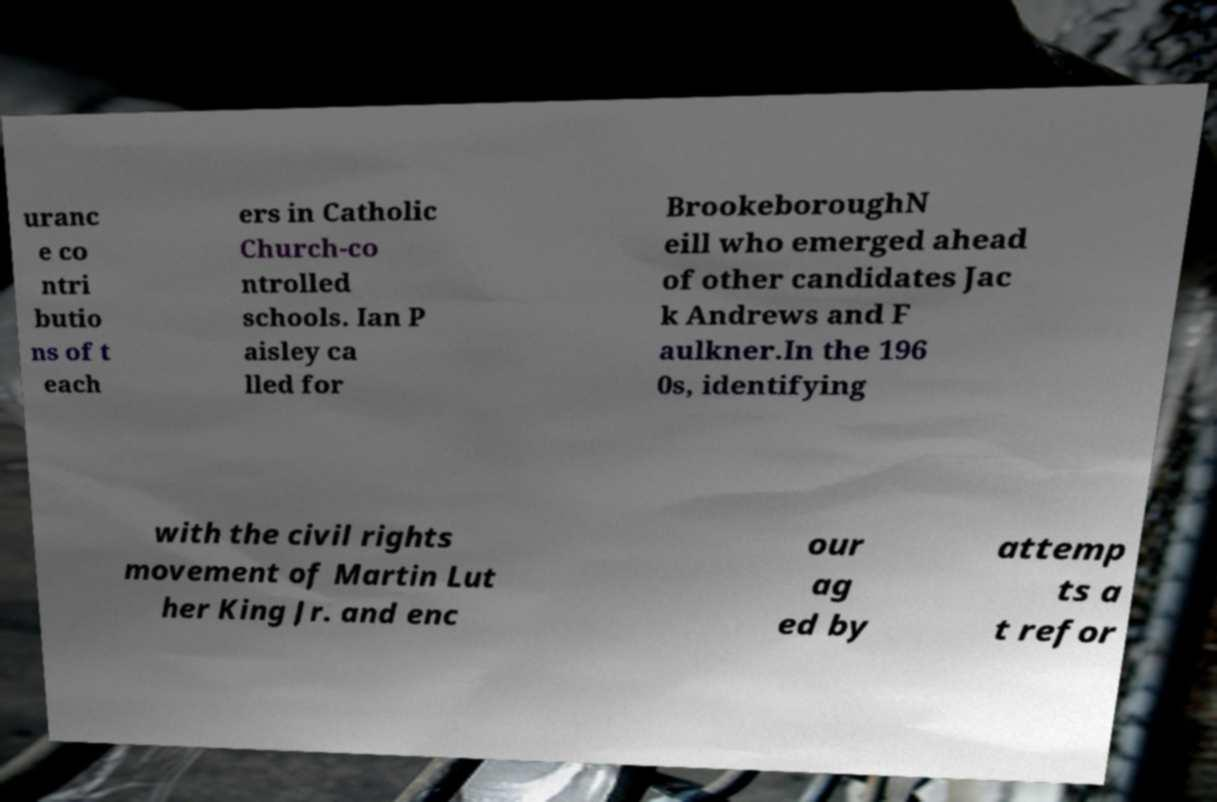Please read and relay the text visible in this image. What does it say? uranc e co ntri butio ns of t each ers in Catholic Church-co ntrolled schools. Ian P aisley ca lled for BrookeboroughN eill who emerged ahead of other candidates Jac k Andrews and F aulkner.In the 196 0s, identifying with the civil rights movement of Martin Lut her King Jr. and enc our ag ed by attemp ts a t refor 